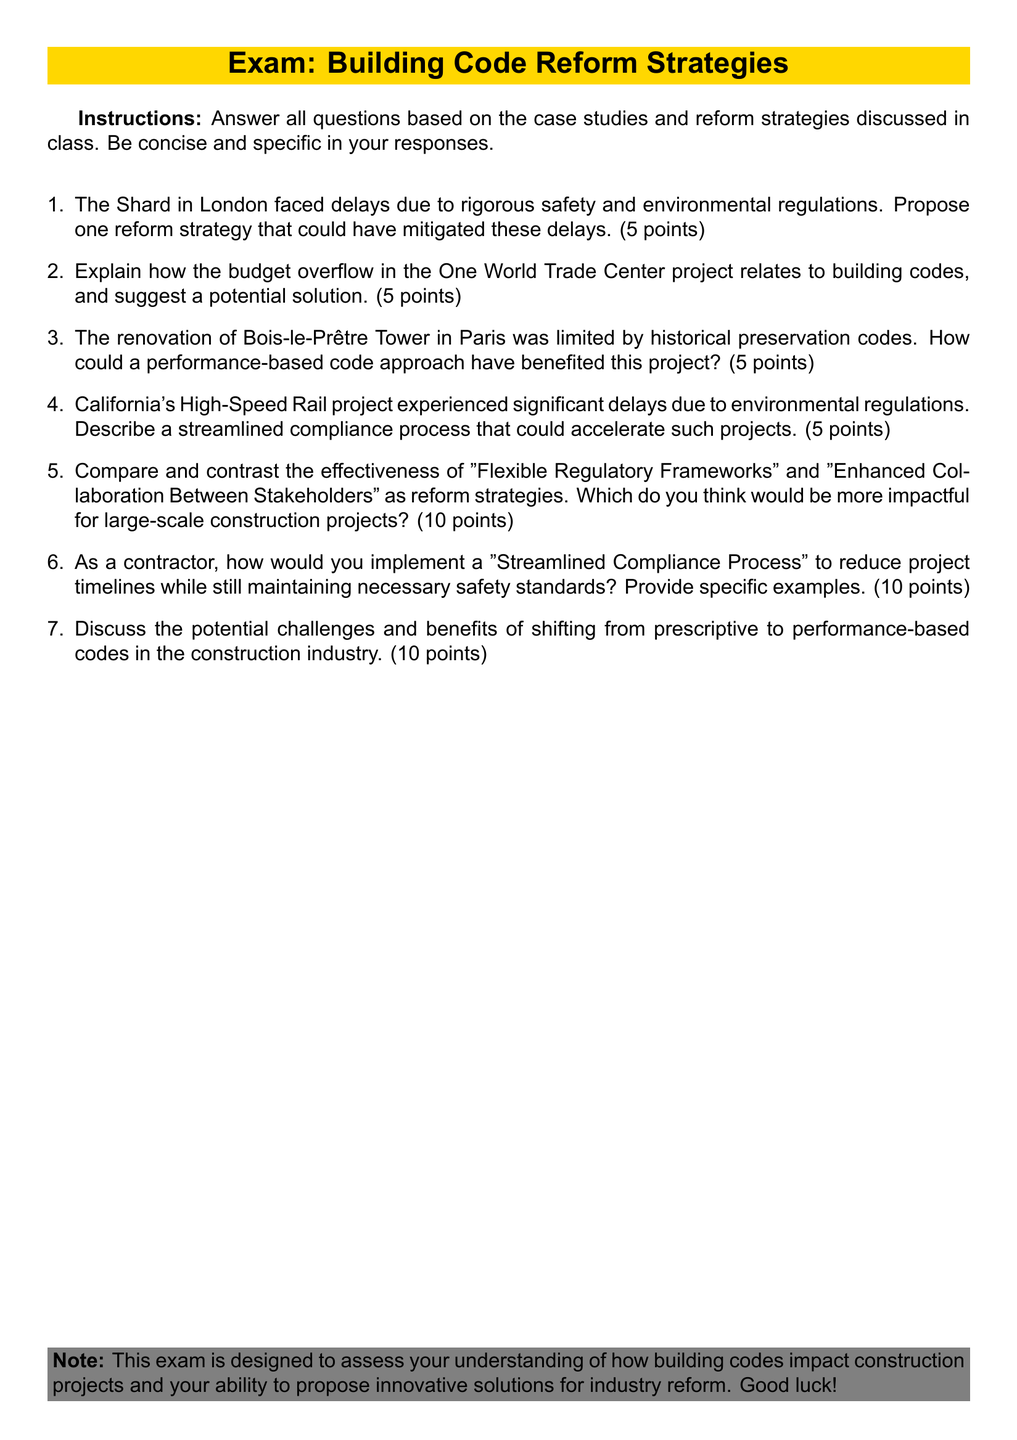What is the title of the exam? The title of the exam is provided in a highlighted box at the beginning, indicating the focus of the document.
Answer: Exam: Building Code Reform Strategies How many points is the first question worth? Each question has a specified point value; the first question is worth five points.
Answer: 5 points Which construction project faced delays due to rigorous safety and environmental regulations? The document mentions a specific project impacted by these regulations.
Answer: The Shard What is one proposed benefit of a performance-based code approach discussed in the document? The renovation of Bois-le-Prêtre Tower implies a benefit of adapting codes that could facilitate the project.
Answer: Benefited this project How many points is the final question worth? The last question is assigned a specific point value outlined in the document; it reveals the question's importance.
Answer: 10 points What two reform strategies are compared in the document? The text provides two specific strategies that are analyzed for effectiveness in large-scale construction.
Answer: Flexible Regulatory Frameworks and Enhanced Collaboration Between Stakeholders What project did California's High-Speed Rail experience delays? The document specifies a particular large-scale infrastructure project facing environmental regulatory challenges.
Answer: California's High-Speed Rail How many questions must be answered in this exam? The examination structure requires addressing all listed questions as it indicates specific instructions regarding them.
Answer: All questions What do the instructions state regarding the responses? The document emphasizes how answers should be framed and what qualities they should retain.
Answer: Be concise and specific 